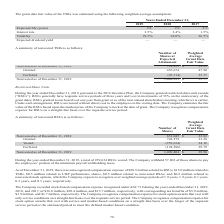According to Aci Worldwide's financial document, How many shares did the company withhold pay the employees’ portion of the minimum payroll withholding taxes in 2019?  According to the financial document, 57,802. The relevant text states: "otal of 259,634 RSUs vested. The Company withheld 57,802 of those shares to pay the employees’ portion of the minimum payroll withholding taxes. As of Decem..." Also, What was the number of granted shares in 2019? According to the financial document, 742,579. The relevant text states: "Granted 742,579 33.28..." Also, What was the number of vested shares in 2019? According to the financial document, 259,634. The relevant text states: "Vested (259,634 ) 24.16..." Also, can you calculate: What was the percentage of vested RSUs that the company withheld to pay the employees’ portion of the minimum payroll withholding taxes in 2019? Based on the calculation: 57,802/259,634, the result is 22.26 (percentage). This is based on the information: "otal of 259,634 RSUs vested. The Company withheld 57,802 of those shares to pay the employees’ portion of the minimum payroll withholding taxes. As of Decem Vested (259,634 ) 24.16..." The key data points involved are: 259,634, 57,802. Also, can you calculate: What was the change in nonvested RSUs between 2018 and 2019? Based on the calculation: 1,009,404-651,045, the result is 358359. This is based on the information: "Nonvested as of December 31, 2018 651,045 $ 23.82 Nonvested as of December 31, 2019 1,009,404 $ 29.96..." The key data points involved are: 1,009,404, 651,045. Also, can you calculate: What was the percentage change in nonvested RSUs between 2018 and 2019? To answer this question, I need to perform calculations using the financial data. The calculation is: (1,009,404-651,045)/651,045, which equals 55.04 (percentage). This is based on the information: "Nonvested as of December 31, 2018 651,045 $ 23.82 Nonvested as of December 31, 2019 1,009,404 $ 29.96..." The key data points involved are: 1,009,404, 651,045. 